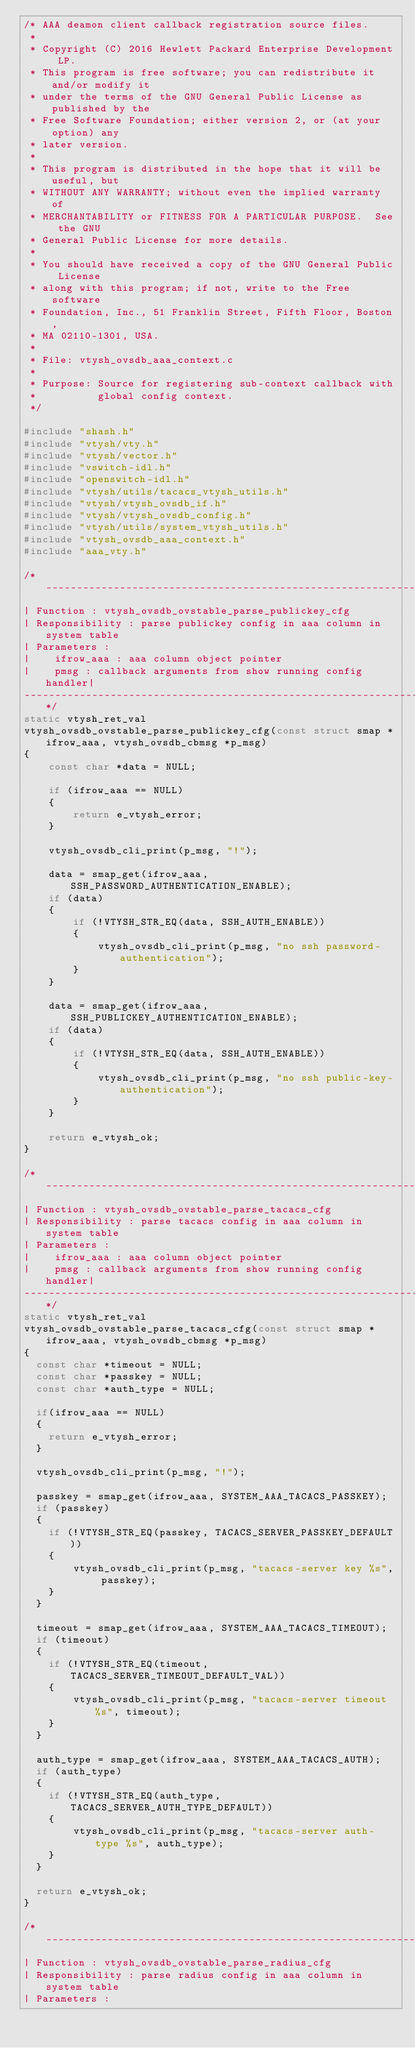Convert code to text. <code><loc_0><loc_0><loc_500><loc_500><_C_>/* AAA deamon client callback registration source files.
 *
 * Copyright (C) 2016 Hewlett Packard Enterprise Development LP.
 * This program is free software; you can redistribute it and/or modify it
 * under the terms of the GNU General Public License as published by the
 * Free Software Foundation; either version 2, or (at your option) any
 * later version.
 *
 * This program is distributed in the hope that it will be useful, but
 * WITHOUT ANY WARRANTY; without even the implied warranty of
 * MERCHANTABILITY or FITNESS FOR A PARTICULAR PURPOSE.  See the GNU
 * General Public License for more details.
 *
 * You should have received a copy of the GNU General Public License
 * along with this program; if not, write to the Free software
 * Foundation, Inc., 51 Franklin Street, Fifth Floor, Boston,
 * MA 02110-1301, USA.
 *
 * File: vtysh_ovsdb_aaa_context.c
 *
 * Purpose: Source for registering sub-context callback with
 *          global config context.
 */

#include "shash.h"
#include "vtysh/vty.h"
#include "vtysh/vector.h"
#include "vswitch-idl.h"
#include "openswitch-idl.h"
#include "vtysh/utils/tacacs_vtysh_utils.h"
#include "vtysh/vtysh_ovsdb_if.h"
#include "vtysh/vtysh_ovsdb_config.h"
#include "vtysh/utils/system_vtysh_utils.h"
#include "vtysh_ovsdb_aaa_context.h"
#include "aaa_vty.h"

/*-----------------------------------------------------------------------------
| Function : vtysh_ovsdb_ovstable_parse_publickey_cfg
| Responsibility : parse publickey config in aaa column in system table
| Parameters :
|    ifrow_aaa : aaa column object pointer
|    pmsg : callback arguments from show running config handler|
-----------------------------------------------------------------------------*/
static vtysh_ret_val
vtysh_ovsdb_ovstable_parse_publickey_cfg(const struct smap *ifrow_aaa, vtysh_ovsdb_cbmsg *p_msg)
{
    const char *data = NULL;

    if (ifrow_aaa == NULL)
    {
        return e_vtysh_error;
    }

    vtysh_ovsdb_cli_print(p_msg, "!");

    data = smap_get(ifrow_aaa, SSH_PASSWORD_AUTHENTICATION_ENABLE);
    if (data)
    {
        if (!VTYSH_STR_EQ(data, SSH_AUTH_ENABLE))
        {
            vtysh_ovsdb_cli_print(p_msg, "no ssh password-authentication");
        }
    }

    data = smap_get(ifrow_aaa, SSH_PUBLICKEY_AUTHENTICATION_ENABLE);
    if (data)
    {
        if (!VTYSH_STR_EQ(data, SSH_AUTH_ENABLE))
        {
            vtysh_ovsdb_cli_print(p_msg, "no ssh public-key-authentication");
        }
    }

    return e_vtysh_ok;
}

/*-----------------------------------------------------------------------------
| Function : vtysh_ovsdb_ovstable_parse_tacacs_cfg
| Responsibility : parse tacacs config in aaa column in system table
| Parameters :
|    ifrow_aaa : aaa column object pointer
|    pmsg : callback arguments from show running config handler|
-----------------------------------------------------------------------------*/
static vtysh_ret_val
vtysh_ovsdb_ovstable_parse_tacacs_cfg(const struct smap *ifrow_aaa, vtysh_ovsdb_cbmsg *p_msg)
{
  const char *timeout = NULL;
  const char *passkey = NULL;
  const char *auth_type = NULL;

  if(ifrow_aaa == NULL)
  {
    return e_vtysh_error;
  }

  vtysh_ovsdb_cli_print(p_msg, "!");

  passkey = smap_get(ifrow_aaa, SYSTEM_AAA_TACACS_PASSKEY);
  if (passkey)
  {
    if (!VTYSH_STR_EQ(passkey, TACACS_SERVER_PASSKEY_DEFAULT))
    {
        vtysh_ovsdb_cli_print(p_msg, "tacacs-server key %s", passkey);
    }
  }

  timeout = smap_get(ifrow_aaa, SYSTEM_AAA_TACACS_TIMEOUT);
  if (timeout)
  {
    if (!VTYSH_STR_EQ(timeout, TACACS_SERVER_TIMEOUT_DEFAULT_VAL))
    {
        vtysh_ovsdb_cli_print(p_msg, "tacacs-server timeout %s", timeout);
    }
  }

  auth_type = smap_get(ifrow_aaa, SYSTEM_AAA_TACACS_AUTH);
  if (auth_type)
  {
    if (!VTYSH_STR_EQ(auth_type, TACACS_SERVER_AUTH_TYPE_DEFAULT))
    {
        vtysh_ovsdb_cli_print(p_msg, "tacacs-server auth-type %s", auth_type);
    }
  }

  return e_vtysh_ok;
}

/*-----------------------------------------------------------------------------
| Function : vtysh_ovsdb_ovstable_parse_radius_cfg
| Responsibility : parse radius config in aaa column in system table
| Parameters :</code> 